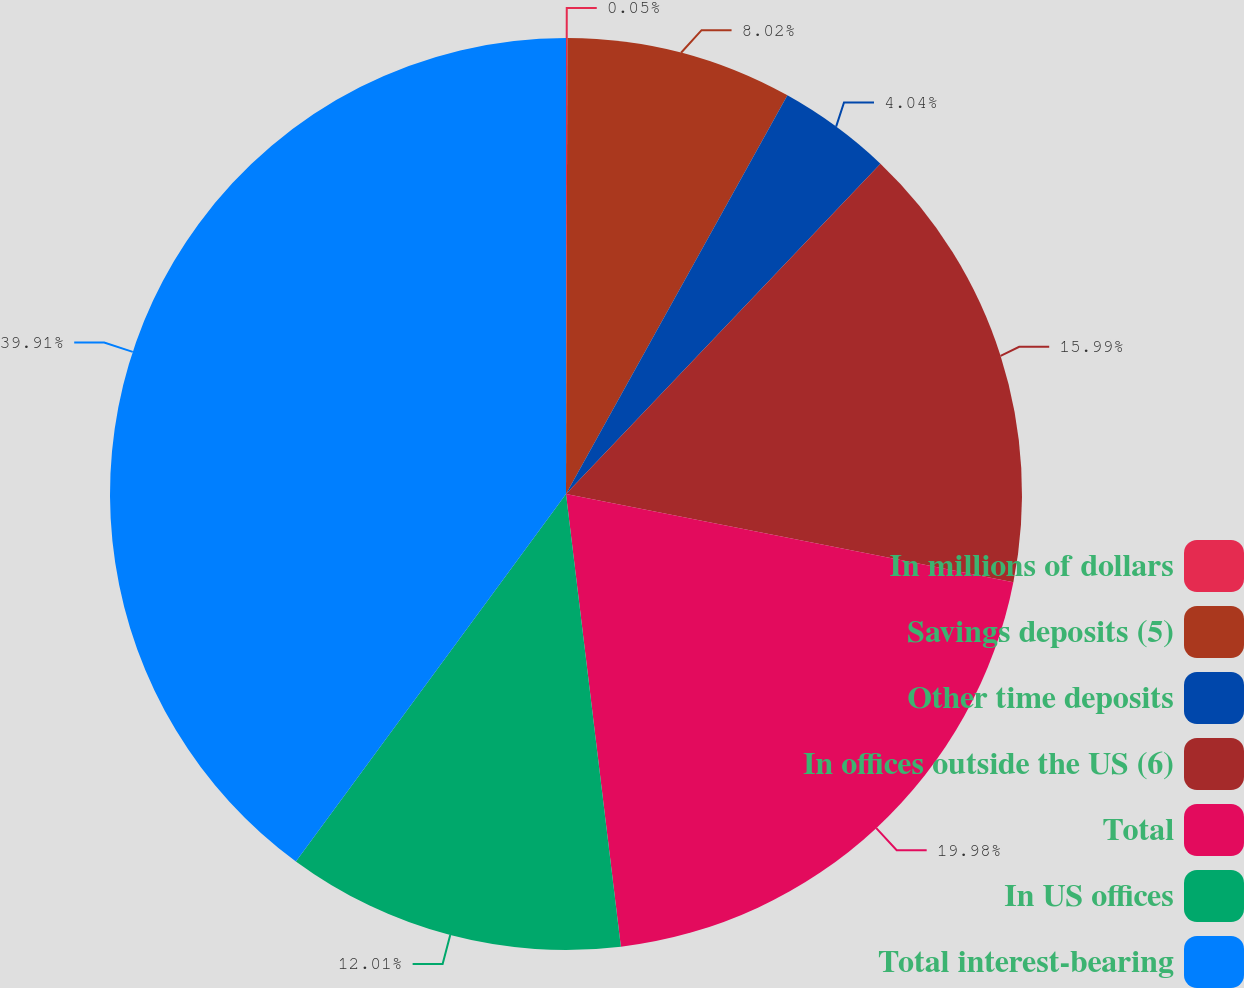<chart> <loc_0><loc_0><loc_500><loc_500><pie_chart><fcel>In millions of dollars<fcel>Savings deposits (5)<fcel>Other time deposits<fcel>In offices outside the US (6)<fcel>Total<fcel>In US offices<fcel>Total interest-bearing<nl><fcel>0.05%<fcel>8.02%<fcel>4.04%<fcel>15.99%<fcel>19.98%<fcel>12.01%<fcel>39.91%<nl></chart> 